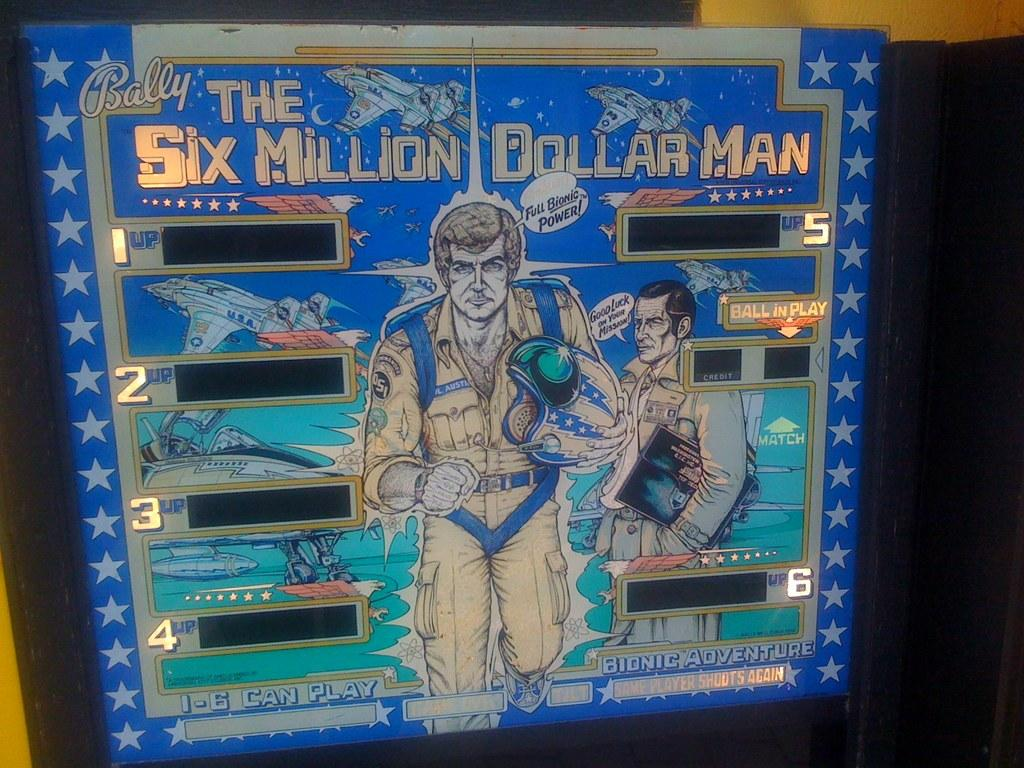Can you describe the setting or context of the image? Unfortunately, there are no specific facts provided about the image, so it is impossible to describe the setting or context. Reasoning: Since there are no facts provided about the image, we cannot create a conversation based on specific details. Instead, we acknowledge the lack of information and avoid making assumptions about the image. Absurd Question/Answer: How many seats are visible in the image? There is no information provided about the image, so it is impossible to determine the number of seats visible. 